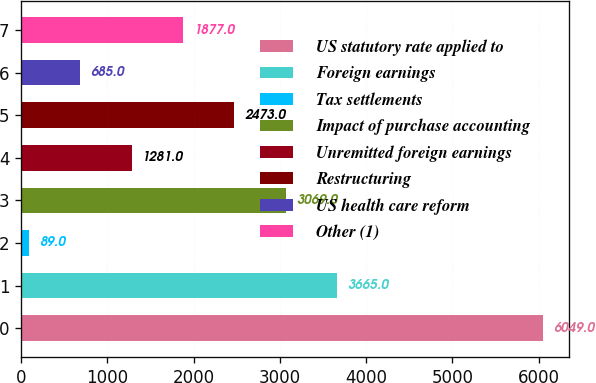Convert chart to OTSL. <chart><loc_0><loc_0><loc_500><loc_500><bar_chart><fcel>US statutory rate applied to<fcel>Foreign earnings<fcel>Tax settlements<fcel>Impact of purchase accounting<fcel>Unremitted foreign earnings<fcel>Restructuring<fcel>US health care reform<fcel>Other (1)<nl><fcel>6049<fcel>3665<fcel>89<fcel>3069<fcel>1281<fcel>2473<fcel>685<fcel>1877<nl></chart> 